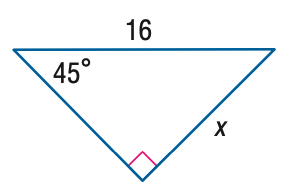Answer the mathemtical geometry problem and directly provide the correct option letter.
Question: Find x.
Choices: A: 8 B: 8 \sqrt { 2 } C: 8 \sqrt { 3 } D: 16 B 